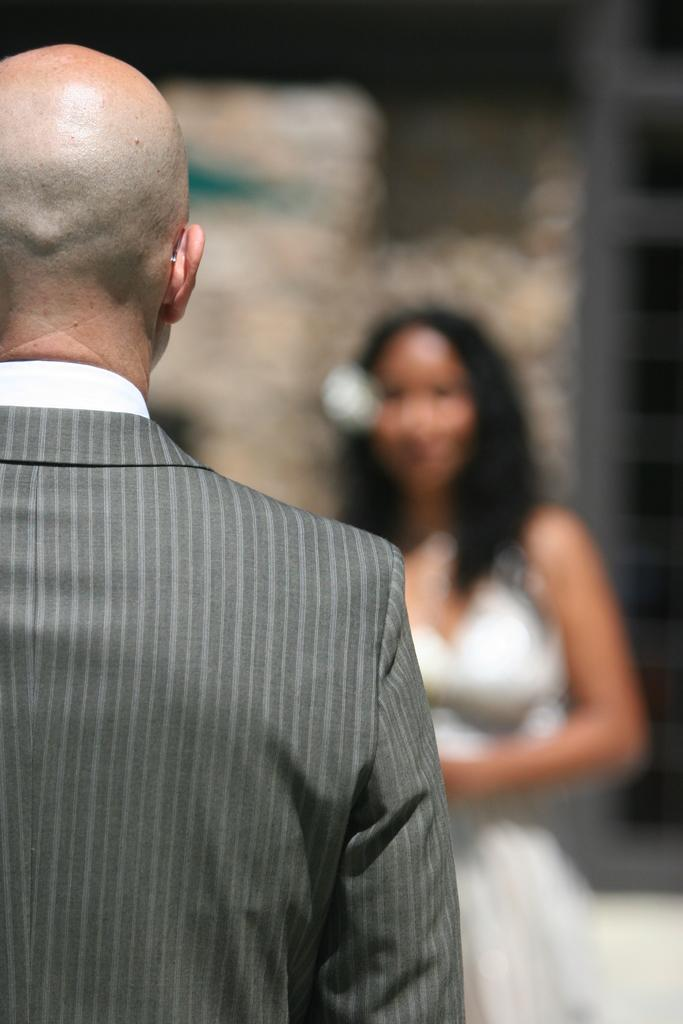What is the person on the left side of the image wearing? The person on the left side of the image is wearing a grey suit. Can you describe the background of the image? The background of the image is blurred. Are there any other people visible in the image besides the person in the grey suit? Yes, there is at least one person visible in the background of the image. What type of jam is being spread on the goldfish in the image? There is no jam or goldfish present in the image. 